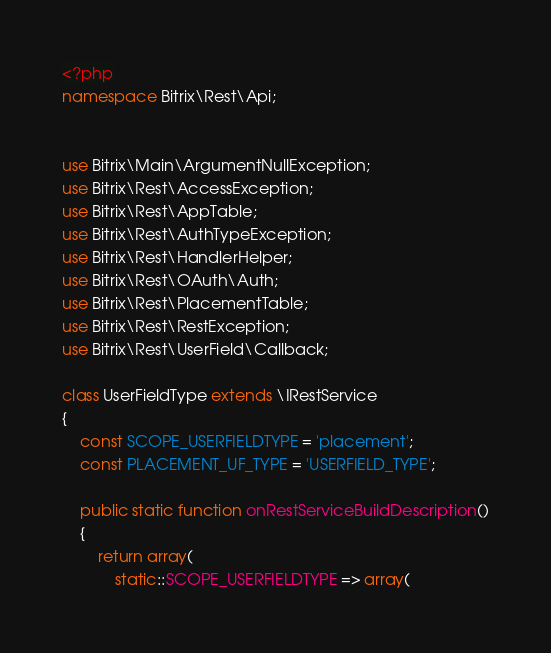<code> <loc_0><loc_0><loc_500><loc_500><_PHP_><?php
namespace Bitrix\Rest\Api;


use Bitrix\Main\ArgumentNullException;
use Bitrix\Rest\AccessException;
use Bitrix\Rest\AppTable;
use Bitrix\Rest\AuthTypeException;
use Bitrix\Rest\HandlerHelper;
use Bitrix\Rest\OAuth\Auth;
use Bitrix\Rest\PlacementTable;
use Bitrix\Rest\RestException;
use Bitrix\Rest\UserField\Callback;

class UserFieldType extends \IRestService
{
	const SCOPE_USERFIELDTYPE = 'placement';
	const PLACEMENT_UF_TYPE = 'USERFIELD_TYPE';

	public static function onRestServiceBuildDescription()
	{
		return array(
			static::SCOPE_USERFIELDTYPE => array(</code> 